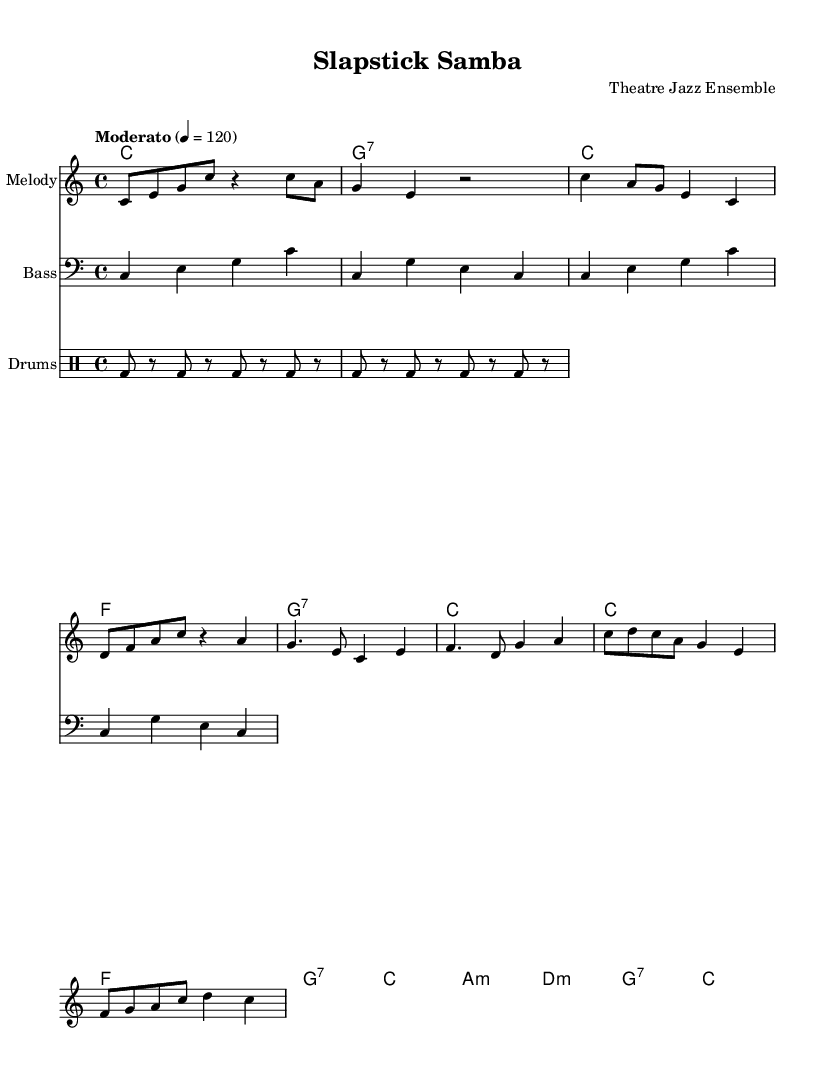What is the key signature of this music? The key signature is C major, which is indicated by the absence of any sharps or flats at the beginning of the staff.
Answer: C major What is the time signature of this piece? The time signature is 4/4, which is presented at the beginning of the score and indicates that there are four beats in each measure, and the quarter note receives one beat.
Answer: 4/4 What is the tempo marking for this composition? The tempo marking states "Moderato" with a metronome marking of 120 beats per minute, which suggests a moderate pace for the performance of the piece.
Answer: Moderato 4 = 120 What is the time signature of the Chorus section? The entire piece maintains the same time signature of 4/4, including the Chorus, which is consistent throughout the score.
Answer: 4/4 How many measures are in the Intro section? The Intro section contains 2 measures, as indicated by the grouping of notes and rests before the Verse begins.
Answer: 2 What is the primary jazz chord used in the Verse? The primary jazz chord used in the Verse section is C major, followed by F major and G dominant seventh, providing a typical progression in jazz.
Answer: C What rhythmic pattern does the drum part primarily use? The drum part primarily utilizes a bass drum pattern with an eighth-note rhythm, creating a typical Latin feel often found in jazz compositions.
Answer: Eighth-note 